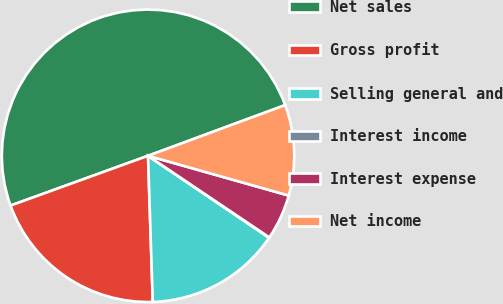Convert chart to OTSL. <chart><loc_0><loc_0><loc_500><loc_500><pie_chart><fcel>Net sales<fcel>Gross profit<fcel>Selling general and<fcel>Interest income<fcel>Interest expense<fcel>Net income<nl><fcel>49.9%<fcel>19.99%<fcel>15.01%<fcel>0.05%<fcel>5.04%<fcel>10.02%<nl></chart> 